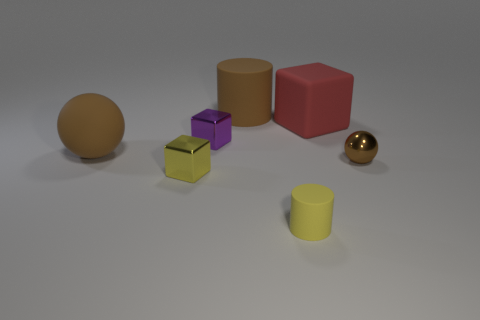How might these objects be used in a learning or educational context? These objects could serve various educational purposes. For instance, they can be used to help children learn about different shapes and colors. The sphere and cylinders can introduce concepts of round shapes and symmetry, while the cubes offer a look at more angular, six-faced solids. The shiny textures of the golden objects could be used to differentiate materials or textures in a tactile learning experience. Furthermore, counting them can be an exercise in basic arithmetic, and arranging them might develop spatial awareness and motor skills. 